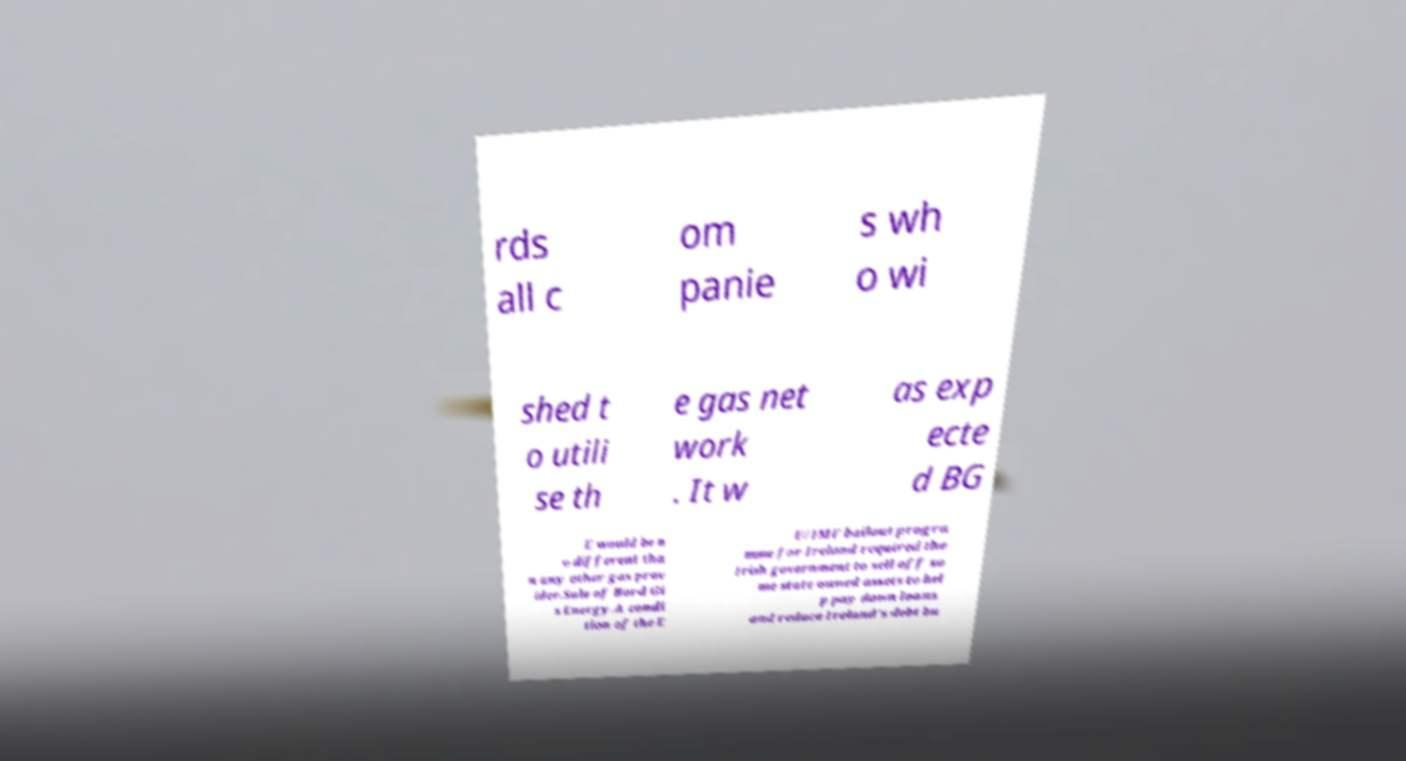Please read and relay the text visible in this image. What does it say? rds all c om panie s wh o wi shed t o utili se th e gas net work . It w as exp ecte d BG E would be n o different tha n any other gas prov ider.Sale of Bord Gi s Energy.A condi tion of the E U/IMF bailout progra mme for Ireland required the Irish government to sell off so me state owned assets to hel p pay down loans and reduce Ireland's debt bu 